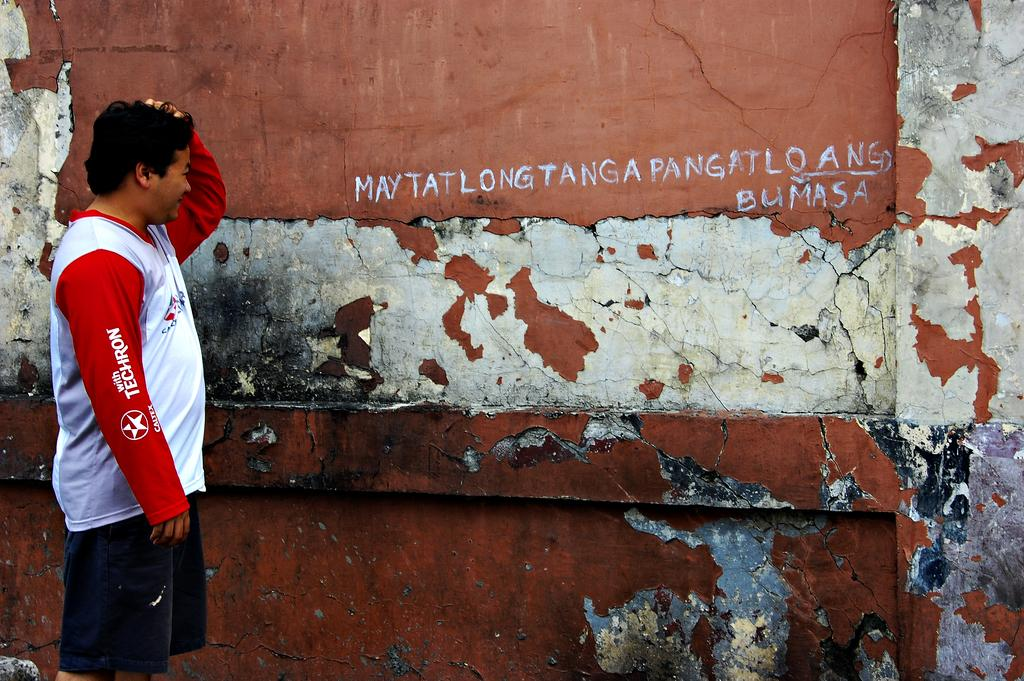What is the position of the man in the image? The man is standing on the left side of the image. What is the man looking at in the image? The man is looking at a wall in the image. What is the man wearing on his upper body? The man is wearing a white and red color t-shirt. What is the man wearing on his lower body? The man is wearing black color shorts. What is a prominent feature in the background of the image? There is a wall in the image. How many ants can be seen crawling on the man's t-shirt in the image? There are no ants visible on the man's t-shirt in the image. What country is the man from in the image? There is no information provided about the man's country of origin in the image. 